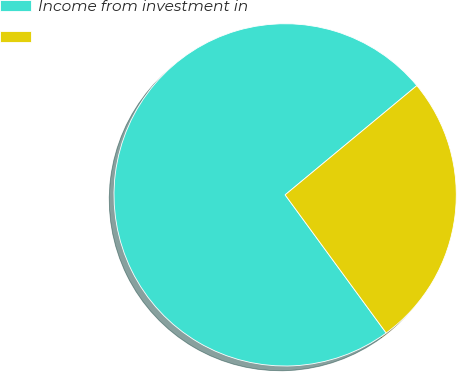Convert chart. <chart><loc_0><loc_0><loc_500><loc_500><pie_chart><fcel>Income from investment in<fcel>Unnamed: 1<nl><fcel>74.03%<fcel>25.97%<nl></chart> 